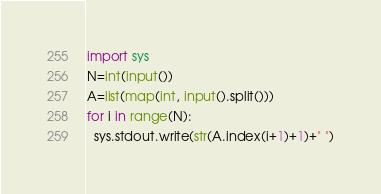<code> <loc_0><loc_0><loc_500><loc_500><_Python_>import sys
N=int(input())
A=list(map(int, input().split()))
for i in range(N):
  sys.stdout.write(str(A.index(i+1)+1)+" ")</code> 